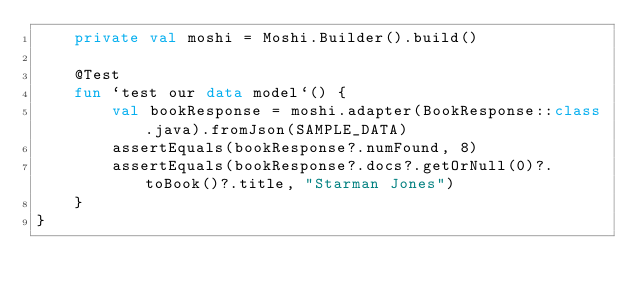<code> <loc_0><loc_0><loc_500><loc_500><_Kotlin_>    private val moshi = Moshi.Builder().build()

    @Test
    fun `test our data model`() {
        val bookResponse = moshi.adapter(BookResponse::class.java).fromJson(SAMPLE_DATA)
        assertEquals(bookResponse?.numFound, 8)
        assertEquals(bookResponse?.docs?.getOrNull(0)?.toBook()?.title, "Starman Jones")
    }
}
</code> 